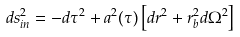<formula> <loc_0><loc_0><loc_500><loc_500>d s ^ { 2 } _ { i n } = - d \tau ^ { 2 } + a ^ { 2 } ( \tau ) \left [ d r ^ { 2 } + r _ { b } ^ { 2 } d \Omega ^ { 2 } \right ]</formula> 